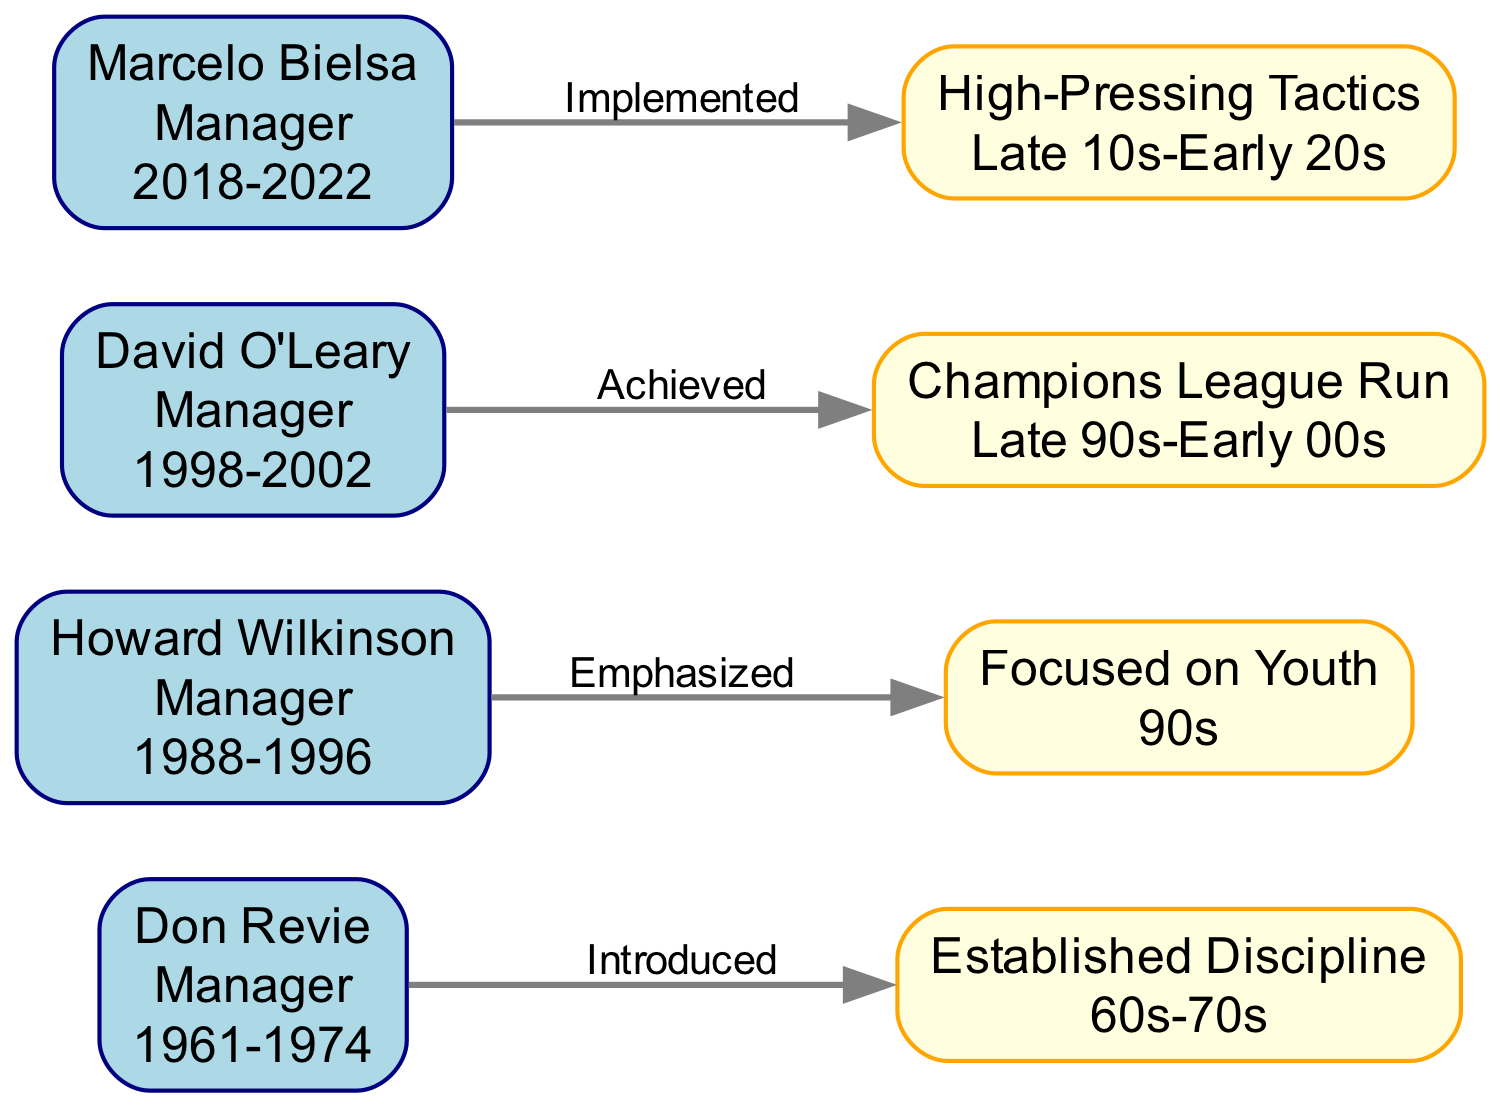What is the role of Don Revie? The node representing Don Revie shows that his role is "Manager." This is explicitly stated in the label of the node.
Answer: Manager How long did Howard Wilkinson manage Leeds United? The node for Howard Wilkinson indicates his management period as "1988-1996." By calculating the years from 1988 to 1996, one can determine the span of his management.
Answer: 8 years What impact is associated with David O'Leary's management? The edge leading from David O'Leary to his impact node states that his management resulted in a "Champions League Run." This is the specific achievement associated with his period.
Answer: Champions League Run Who introduced established discipline in the 60s-70s? The diagram shows that Don Revie is linked to the "Established Discipline" impact node with the relationship "Introduced." This indicates that he was responsible for this aspect during his period.
Answer: Don Revie How many managers are represented in the diagram? To find the total number of managers, one can count the unique nodes categorized as "Manager." Based on the nodes listed, there are four managers: Don Revie, Howard Wilkinson, David O'Leary, and Marcelo Bielsa.
Answer: 4 What kind of tactics did Marcelo Bielsa implement? The edge from Marcelo Bielsa to the corresponding impact node indicates he "Implemented" "High-Pressing Tactics." This detail is crucial for understanding his management approach.
Answer: High-Pressing Tactics Which manager emphasized youth? The connection between Howard Wilkinson and his impact node with the relationship "Emphasized" shows that he emphasized focusing on youth. This links his management philosophy directly to the impact node.
Answer: Howard Wilkinson What time period did the Revie Era impact cover? The impact node labeled "Established Discipline" states that it covered the period "60s-70s." This directly answers the question regarding the timeframe of this management style's impact.
Answer: 60s-70s In what year did Marcelo Bielsa's management start? The node for Marcelo Bielsa indicates that his management period began in "2018." This specific starting year is highlighted in his node.
Answer: 2018 